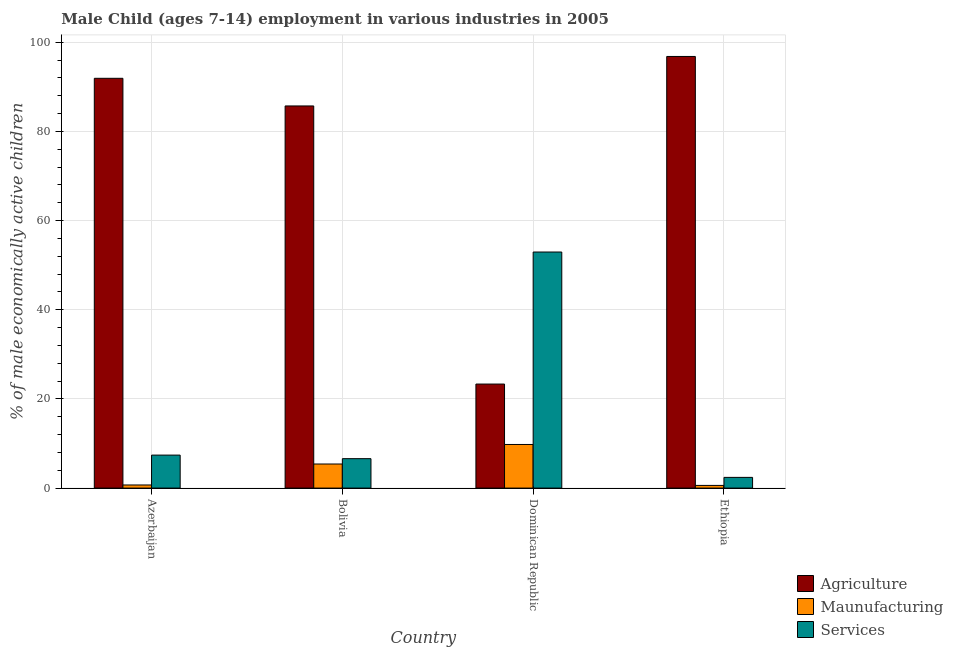How many different coloured bars are there?
Ensure brevity in your answer.  3. How many groups of bars are there?
Provide a short and direct response. 4. Are the number of bars per tick equal to the number of legend labels?
Offer a terse response. Yes. Are the number of bars on each tick of the X-axis equal?
Make the answer very short. Yes. How many bars are there on the 1st tick from the left?
Offer a very short reply. 3. How many bars are there on the 3rd tick from the right?
Keep it short and to the point. 3. What is the label of the 1st group of bars from the left?
Keep it short and to the point. Azerbaijan. In how many cases, is the number of bars for a given country not equal to the number of legend labels?
Provide a short and direct response. 0. What is the percentage of economically active children in agriculture in Ethiopia?
Offer a very short reply. 96.8. Across all countries, what is the maximum percentage of economically active children in manufacturing?
Ensure brevity in your answer.  9.78. Across all countries, what is the minimum percentage of economically active children in manufacturing?
Your answer should be very brief. 0.6. In which country was the percentage of economically active children in manufacturing maximum?
Your response must be concise. Dominican Republic. In which country was the percentage of economically active children in services minimum?
Give a very brief answer. Ethiopia. What is the total percentage of economically active children in services in the graph?
Your response must be concise. 69.34. What is the difference between the percentage of economically active children in agriculture in Bolivia and that in Ethiopia?
Offer a very short reply. -11.1. What is the difference between the percentage of economically active children in services in Bolivia and the percentage of economically active children in agriculture in Azerbaijan?
Ensure brevity in your answer.  -85.3. What is the average percentage of economically active children in manufacturing per country?
Your answer should be very brief. 4.12. What is the difference between the percentage of economically active children in agriculture and percentage of economically active children in manufacturing in Azerbaijan?
Offer a terse response. 91.2. What is the ratio of the percentage of economically active children in agriculture in Dominican Republic to that in Ethiopia?
Your answer should be very brief. 0.24. Is the percentage of economically active children in services in Azerbaijan less than that in Ethiopia?
Make the answer very short. No. Is the difference between the percentage of economically active children in services in Dominican Republic and Ethiopia greater than the difference between the percentage of economically active children in agriculture in Dominican Republic and Ethiopia?
Keep it short and to the point. Yes. What is the difference between the highest and the second highest percentage of economically active children in agriculture?
Provide a succinct answer. 4.9. What is the difference between the highest and the lowest percentage of economically active children in services?
Keep it short and to the point. 50.54. What does the 1st bar from the left in Bolivia represents?
Keep it short and to the point. Agriculture. What does the 2nd bar from the right in Ethiopia represents?
Your answer should be very brief. Maunufacturing. Are all the bars in the graph horizontal?
Provide a succinct answer. No. What is the difference between two consecutive major ticks on the Y-axis?
Provide a short and direct response. 20. Does the graph contain any zero values?
Make the answer very short. No. Does the graph contain grids?
Your answer should be very brief. Yes. How are the legend labels stacked?
Provide a short and direct response. Vertical. What is the title of the graph?
Keep it short and to the point. Male Child (ages 7-14) employment in various industries in 2005. What is the label or title of the X-axis?
Offer a very short reply. Country. What is the label or title of the Y-axis?
Your answer should be very brief. % of male economically active children. What is the % of male economically active children in Agriculture in Azerbaijan?
Give a very brief answer. 91.9. What is the % of male economically active children of Agriculture in Bolivia?
Keep it short and to the point. 85.7. What is the % of male economically active children in Services in Bolivia?
Provide a succinct answer. 6.6. What is the % of male economically active children in Agriculture in Dominican Republic?
Your response must be concise. 23.33. What is the % of male economically active children in Maunufacturing in Dominican Republic?
Offer a terse response. 9.78. What is the % of male economically active children in Services in Dominican Republic?
Your response must be concise. 52.94. What is the % of male economically active children in Agriculture in Ethiopia?
Make the answer very short. 96.8. What is the % of male economically active children in Maunufacturing in Ethiopia?
Your response must be concise. 0.6. Across all countries, what is the maximum % of male economically active children in Agriculture?
Give a very brief answer. 96.8. Across all countries, what is the maximum % of male economically active children in Maunufacturing?
Provide a succinct answer. 9.78. Across all countries, what is the maximum % of male economically active children in Services?
Offer a terse response. 52.94. Across all countries, what is the minimum % of male economically active children of Agriculture?
Make the answer very short. 23.33. What is the total % of male economically active children in Agriculture in the graph?
Ensure brevity in your answer.  297.73. What is the total % of male economically active children in Maunufacturing in the graph?
Your response must be concise. 16.48. What is the total % of male economically active children in Services in the graph?
Ensure brevity in your answer.  69.34. What is the difference between the % of male economically active children of Agriculture in Azerbaijan and that in Bolivia?
Give a very brief answer. 6.2. What is the difference between the % of male economically active children in Agriculture in Azerbaijan and that in Dominican Republic?
Ensure brevity in your answer.  68.57. What is the difference between the % of male economically active children in Maunufacturing in Azerbaijan and that in Dominican Republic?
Provide a succinct answer. -9.08. What is the difference between the % of male economically active children of Services in Azerbaijan and that in Dominican Republic?
Provide a short and direct response. -45.54. What is the difference between the % of male economically active children in Services in Azerbaijan and that in Ethiopia?
Offer a very short reply. 5. What is the difference between the % of male economically active children of Agriculture in Bolivia and that in Dominican Republic?
Make the answer very short. 62.37. What is the difference between the % of male economically active children of Maunufacturing in Bolivia and that in Dominican Republic?
Offer a very short reply. -4.38. What is the difference between the % of male economically active children of Services in Bolivia and that in Dominican Republic?
Provide a short and direct response. -46.34. What is the difference between the % of male economically active children in Agriculture in Bolivia and that in Ethiopia?
Give a very brief answer. -11.1. What is the difference between the % of male economically active children in Maunufacturing in Bolivia and that in Ethiopia?
Give a very brief answer. 4.8. What is the difference between the % of male economically active children in Agriculture in Dominican Republic and that in Ethiopia?
Your response must be concise. -73.47. What is the difference between the % of male economically active children of Maunufacturing in Dominican Republic and that in Ethiopia?
Give a very brief answer. 9.18. What is the difference between the % of male economically active children of Services in Dominican Republic and that in Ethiopia?
Keep it short and to the point. 50.54. What is the difference between the % of male economically active children in Agriculture in Azerbaijan and the % of male economically active children in Maunufacturing in Bolivia?
Offer a very short reply. 86.5. What is the difference between the % of male economically active children of Agriculture in Azerbaijan and the % of male economically active children of Services in Bolivia?
Your response must be concise. 85.3. What is the difference between the % of male economically active children of Maunufacturing in Azerbaijan and the % of male economically active children of Services in Bolivia?
Offer a terse response. -5.9. What is the difference between the % of male economically active children of Agriculture in Azerbaijan and the % of male economically active children of Maunufacturing in Dominican Republic?
Offer a terse response. 82.12. What is the difference between the % of male economically active children of Agriculture in Azerbaijan and the % of male economically active children of Services in Dominican Republic?
Offer a very short reply. 38.96. What is the difference between the % of male economically active children in Maunufacturing in Azerbaijan and the % of male economically active children in Services in Dominican Republic?
Your answer should be very brief. -52.24. What is the difference between the % of male economically active children of Agriculture in Azerbaijan and the % of male economically active children of Maunufacturing in Ethiopia?
Make the answer very short. 91.3. What is the difference between the % of male economically active children in Agriculture in Azerbaijan and the % of male economically active children in Services in Ethiopia?
Provide a succinct answer. 89.5. What is the difference between the % of male economically active children of Agriculture in Bolivia and the % of male economically active children of Maunufacturing in Dominican Republic?
Offer a very short reply. 75.92. What is the difference between the % of male economically active children of Agriculture in Bolivia and the % of male economically active children of Services in Dominican Republic?
Keep it short and to the point. 32.76. What is the difference between the % of male economically active children in Maunufacturing in Bolivia and the % of male economically active children in Services in Dominican Republic?
Your answer should be very brief. -47.54. What is the difference between the % of male economically active children of Agriculture in Bolivia and the % of male economically active children of Maunufacturing in Ethiopia?
Provide a succinct answer. 85.1. What is the difference between the % of male economically active children in Agriculture in Bolivia and the % of male economically active children in Services in Ethiopia?
Provide a short and direct response. 83.3. What is the difference between the % of male economically active children in Maunufacturing in Bolivia and the % of male economically active children in Services in Ethiopia?
Ensure brevity in your answer.  3. What is the difference between the % of male economically active children in Agriculture in Dominican Republic and the % of male economically active children in Maunufacturing in Ethiopia?
Provide a short and direct response. 22.73. What is the difference between the % of male economically active children in Agriculture in Dominican Republic and the % of male economically active children in Services in Ethiopia?
Offer a very short reply. 20.93. What is the difference between the % of male economically active children in Maunufacturing in Dominican Republic and the % of male economically active children in Services in Ethiopia?
Ensure brevity in your answer.  7.38. What is the average % of male economically active children of Agriculture per country?
Your answer should be compact. 74.43. What is the average % of male economically active children of Maunufacturing per country?
Keep it short and to the point. 4.12. What is the average % of male economically active children in Services per country?
Keep it short and to the point. 17.34. What is the difference between the % of male economically active children in Agriculture and % of male economically active children in Maunufacturing in Azerbaijan?
Offer a terse response. 91.2. What is the difference between the % of male economically active children in Agriculture and % of male economically active children in Services in Azerbaijan?
Offer a terse response. 84.5. What is the difference between the % of male economically active children of Maunufacturing and % of male economically active children of Services in Azerbaijan?
Your answer should be very brief. -6.7. What is the difference between the % of male economically active children in Agriculture and % of male economically active children in Maunufacturing in Bolivia?
Provide a succinct answer. 80.3. What is the difference between the % of male economically active children of Agriculture and % of male economically active children of Services in Bolivia?
Your response must be concise. 79.1. What is the difference between the % of male economically active children in Agriculture and % of male economically active children in Maunufacturing in Dominican Republic?
Your response must be concise. 13.55. What is the difference between the % of male economically active children in Agriculture and % of male economically active children in Services in Dominican Republic?
Make the answer very short. -29.61. What is the difference between the % of male economically active children of Maunufacturing and % of male economically active children of Services in Dominican Republic?
Your response must be concise. -43.16. What is the difference between the % of male economically active children of Agriculture and % of male economically active children of Maunufacturing in Ethiopia?
Your answer should be compact. 96.2. What is the difference between the % of male economically active children in Agriculture and % of male economically active children in Services in Ethiopia?
Make the answer very short. 94.4. What is the difference between the % of male economically active children of Maunufacturing and % of male economically active children of Services in Ethiopia?
Keep it short and to the point. -1.8. What is the ratio of the % of male economically active children in Agriculture in Azerbaijan to that in Bolivia?
Make the answer very short. 1.07. What is the ratio of the % of male economically active children in Maunufacturing in Azerbaijan to that in Bolivia?
Give a very brief answer. 0.13. What is the ratio of the % of male economically active children of Services in Azerbaijan to that in Bolivia?
Provide a succinct answer. 1.12. What is the ratio of the % of male economically active children of Agriculture in Azerbaijan to that in Dominican Republic?
Offer a terse response. 3.94. What is the ratio of the % of male economically active children of Maunufacturing in Azerbaijan to that in Dominican Republic?
Give a very brief answer. 0.07. What is the ratio of the % of male economically active children of Services in Azerbaijan to that in Dominican Republic?
Make the answer very short. 0.14. What is the ratio of the % of male economically active children in Agriculture in Azerbaijan to that in Ethiopia?
Make the answer very short. 0.95. What is the ratio of the % of male economically active children of Services in Azerbaijan to that in Ethiopia?
Ensure brevity in your answer.  3.08. What is the ratio of the % of male economically active children in Agriculture in Bolivia to that in Dominican Republic?
Give a very brief answer. 3.67. What is the ratio of the % of male economically active children in Maunufacturing in Bolivia to that in Dominican Republic?
Your response must be concise. 0.55. What is the ratio of the % of male economically active children of Services in Bolivia to that in Dominican Republic?
Make the answer very short. 0.12. What is the ratio of the % of male economically active children of Agriculture in Bolivia to that in Ethiopia?
Provide a succinct answer. 0.89. What is the ratio of the % of male economically active children of Maunufacturing in Bolivia to that in Ethiopia?
Your answer should be compact. 9. What is the ratio of the % of male economically active children in Services in Bolivia to that in Ethiopia?
Make the answer very short. 2.75. What is the ratio of the % of male economically active children in Agriculture in Dominican Republic to that in Ethiopia?
Offer a terse response. 0.24. What is the ratio of the % of male economically active children of Maunufacturing in Dominican Republic to that in Ethiopia?
Ensure brevity in your answer.  16.3. What is the ratio of the % of male economically active children of Services in Dominican Republic to that in Ethiopia?
Provide a succinct answer. 22.06. What is the difference between the highest and the second highest % of male economically active children of Maunufacturing?
Give a very brief answer. 4.38. What is the difference between the highest and the second highest % of male economically active children of Services?
Offer a very short reply. 45.54. What is the difference between the highest and the lowest % of male economically active children in Agriculture?
Keep it short and to the point. 73.47. What is the difference between the highest and the lowest % of male economically active children of Maunufacturing?
Keep it short and to the point. 9.18. What is the difference between the highest and the lowest % of male economically active children in Services?
Provide a succinct answer. 50.54. 